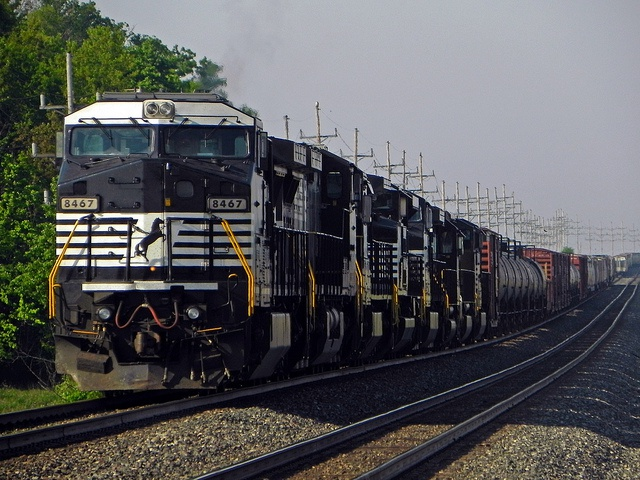Describe the objects in this image and their specific colors. I can see a train in darkgreen, black, gray, and darkgray tones in this image. 